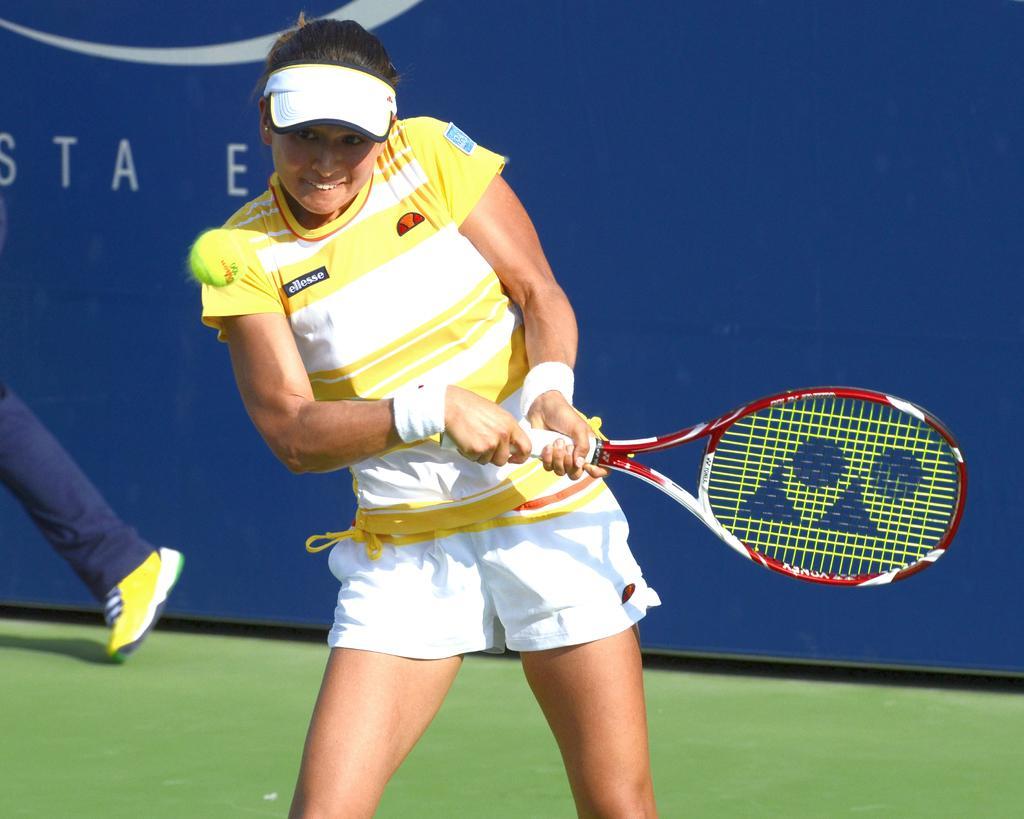How would you summarize this image in a sentence or two? In this image I can see if a woman is standing and holding a racket. I can also see a ball and she is wearing a cap. I can see she is wearing shorts and a t-shirt. In the background I can see a leg of a person. 